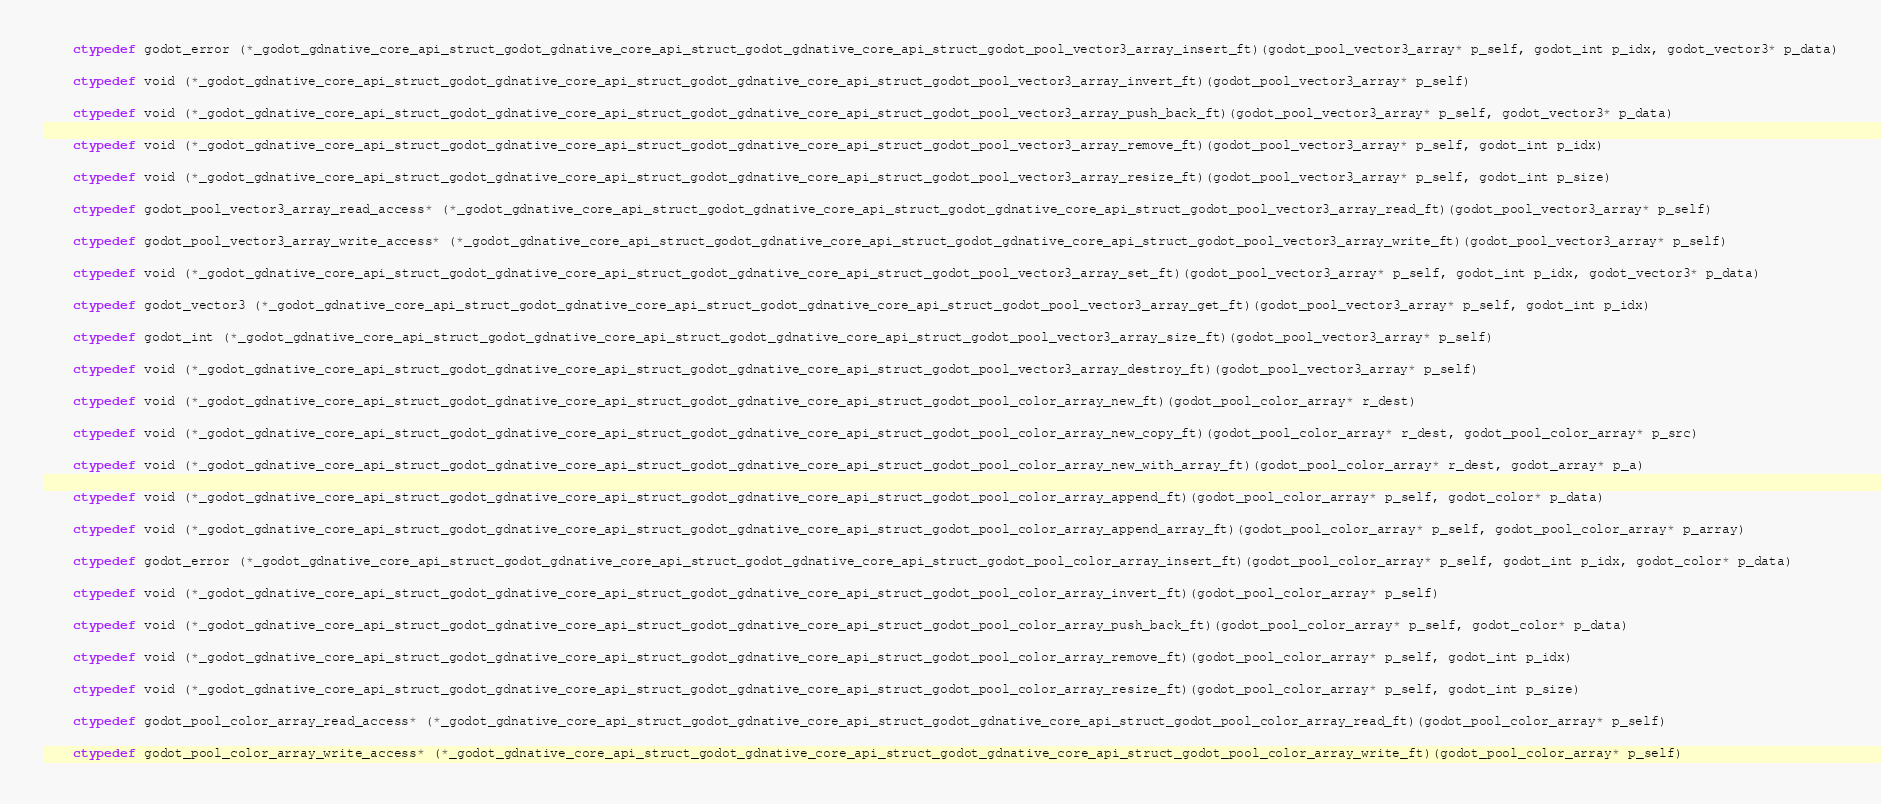<code> <loc_0><loc_0><loc_500><loc_500><_Cython_>    ctypedef godot_error (*_godot_gdnative_core_api_struct_godot_gdnative_core_api_struct_godot_gdnative_core_api_struct_godot_pool_vector3_array_insert_ft)(godot_pool_vector3_array* p_self, godot_int p_idx, godot_vector3* p_data)

    ctypedef void (*_godot_gdnative_core_api_struct_godot_gdnative_core_api_struct_godot_gdnative_core_api_struct_godot_pool_vector3_array_invert_ft)(godot_pool_vector3_array* p_self)

    ctypedef void (*_godot_gdnative_core_api_struct_godot_gdnative_core_api_struct_godot_gdnative_core_api_struct_godot_pool_vector3_array_push_back_ft)(godot_pool_vector3_array* p_self, godot_vector3* p_data)

    ctypedef void (*_godot_gdnative_core_api_struct_godot_gdnative_core_api_struct_godot_gdnative_core_api_struct_godot_pool_vector3_array_remove_ft)(godot_pool_vector3_array* p_self, godot_int p_idx)

    ctypedef void (*_godot_gdnative_core_api_struct_godot_gdnative_core_api_struct_godot_gdnative_core_api_struct_godot_pool_vector3_array_resize_ft)(godot_pool_vector3_array* p_self, godot_int p_size)

    ctypedef godot_pool_vector3_array_read_access* (*_godot_gdnative_core_api_struct_godot_gdnative_core_api_struct_godot_gdnative_core_api_struct_godot_pool_vector3_array_read_ft)(godot_pool_vector3_array* p_self)

    ctypedef godot_pool_vector3_array_write_access* (*_godot_gdnative_core_api_struct_godot_gdnative_core_api_struct_godot_gdnative_core_api_struct_godot_pool_vector3_array_write_ft)(godot_pool_vector3_array* p_self)

    ctypedef void (*_godot_gdnative_core_api_struct_godot_gdnative_core_api_struct_godot_gdnative_core_api_struct_godot_pool_vector3_array_set_ft)(godot_pool_vector3_array* p_self, godot_int p_idx, godot_vector3* p_data)

    ctypedef godot_vector3 (*_godot_gdnative_core_api_struct_godot_gdnative_core_api_struct_godot_gdnative_core_api_struct_godot_pool_vector3_array_get_ft)(godot_pool_vector3_array* p_self, godot_int p_idx)

    ctypedef godot_int (*_godot_gdnative_core_api_struct_godot_gdnative_core_api_struct_godot_gdnative_core_api_struct_godot_pool_vector3_array_size_ft)(godot_pool_vector3_array* p_self)

    ctypedef void (*_godot_gdnative_core_api_struct_godot_gdnative_core_api_struct_godot_gdnative_core_api_struct_godot_pool_vector3_array_destroy_ft)(godot_pool_vector3_array* p_self)

    ctypedef void (*_godot_gdnative_core_api_struct_godot_gdnative_core_api_struct_godot_gdnative_core_api_struct_godot_pool_color_array_new_ft)(godot_pool_color_array* r_dest)

    ctypedef void (*_godot_gdnative_core_api_struct_godot_gdnative_core_api_struct_godot_gdnative_core_api_struct_godot_pool_color_array_new_copy_ft)(godot_pool_color_array* r_dest, godot_pool_color_array* p_src)

    ctypedef void (*_godot_gdnative_core_api_struct_godot_gdnative_core_api_struct_godot_gdnative_core_api_struct_godot_pool_color_array_new_with_array_ft)(godot_pool_color_array* r_dest, godot_array* p_a)

    ctypedef void (*_godot_gdnative_core_api_struct_godot_gdnative_core_api_struct_godot_gdnative_core_api_struct_godot_pool_color_array_append_ft)(godot_pool_color_array* p_self, godot_color* p_data)

    ctypedef void (*_godot_gdnative_core_api_struct_godot_gdnative_core_api_struct_godot_gdnative_core_api_struct_godot_pool_color_array_append_array_ft)(godot_pool_color_array* p_self, godot_pool_color_array* p_array)

    ctypedef godot_error (*_godot_gdnative_core_api_struct_godot_gdnative_core_api_struct_godot_gdnative_core_api_struct_godot_pool_color_array_insert_ft)(godot_pool_color_array* p_self, godot_int p_idx, godot_color* p_data)

    ctypedef void (*_godot_gdnative_core_api_struct_godot_gdnative_core_api_struct_godot_gdnative_core_api_struct_godot_pool_color_array_invert_ft)(godot_pool_color_array* p_self)

    ctypedef void (*_godot_gdnative_core_api_struct_godot_gdnative_core_api_struct_godot_gdnative_core_api_struct_godot_pool_color_array_push_back_ft)(godot_pool_color_array* p_self, godot_color* p_data)

    ctypedef void (*_godot_gdnative_core_api_struct_godot_gdnative_core_api_struct_godot_gdnative_core_api_struct_godot_pool_color_array_remove_ft)(godot_pool_color_array* p_self, godot_int p_idx)

    ctypedef void (*_godot_gdnative_core_api_struct_godot_gdnative_core_api_struct_godot_gdnative_core_api_struct_godot_pool_color_array_resize_ft)(godot_pool_color_array* p_self, godot_int p_size)

    ctypedef godot_pool_color_array_read_access* (*_godot_gdnative_core_api_struct_godot_gdnative_core_api_struct_godot_gdnative_core_api_struct_godot_pool_color_array_read_ft)(godot_pool_color_array* p_self)

    ctypedef godot_pool_color_array_write_access* (*_godot_gdnative_core_api_struct_godot_gdnative_core_api_struct_godot_gdnative_core_api_struct_godot_pool_color_array_write_ft)(godot_pool_color_array* p_self)
</code> 